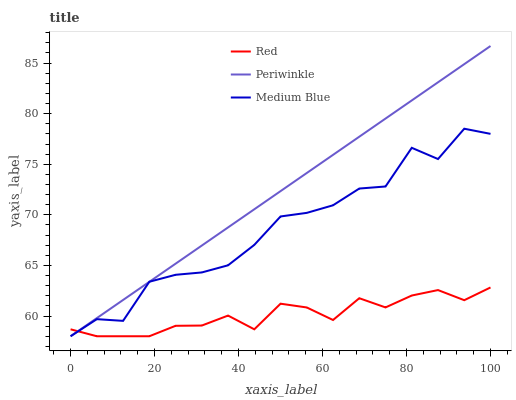Does Red have the minimum area under the curve?
Answer yes or no. Yes. Does Periwinkle have the maximum area under the curve?
Answer yes or no. Yes. Does Periwinkle have the minimum area under the curve?
Answer yes or no. No. Does Red have the maximum area under the curve?
Answer yes or no. No. Is Periwinkle the smoothest?
Answer yes or no. Yes. Is Medium Blue the roughest?
Answer yes or no. Yes. Is Red the smoothest?
Answer yes or no. No. Is Red the roughest?
Answer yes or no. No. Does Medium Blue have the lowest value?
Answer yes or no. Yes. Does Periwinkle have the highest value?
Answer yes or no. Yes. Does Red have the highest value?
Answer yes or no. No. Does Medium Blue intersect Red?
Answer yes or no. Yes. Is Medium Blue less than Red?
Answer yes or no. No. Is Medium Blue greater than Red?
Answer yes or no. No. 